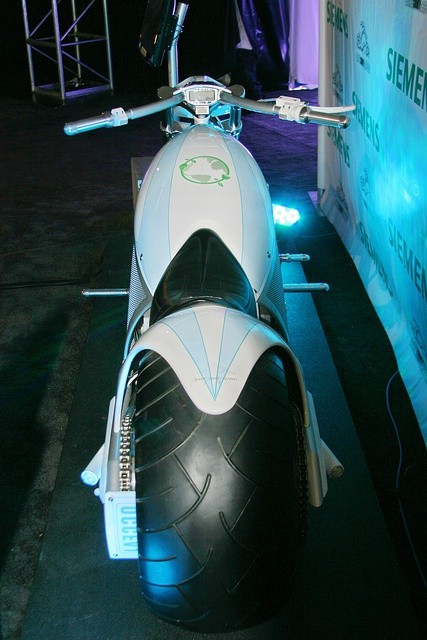Describe the objects in this image and their specific colors. I can see a motorcycle in black, lightgray, lightblue, and gray tones in this image. 